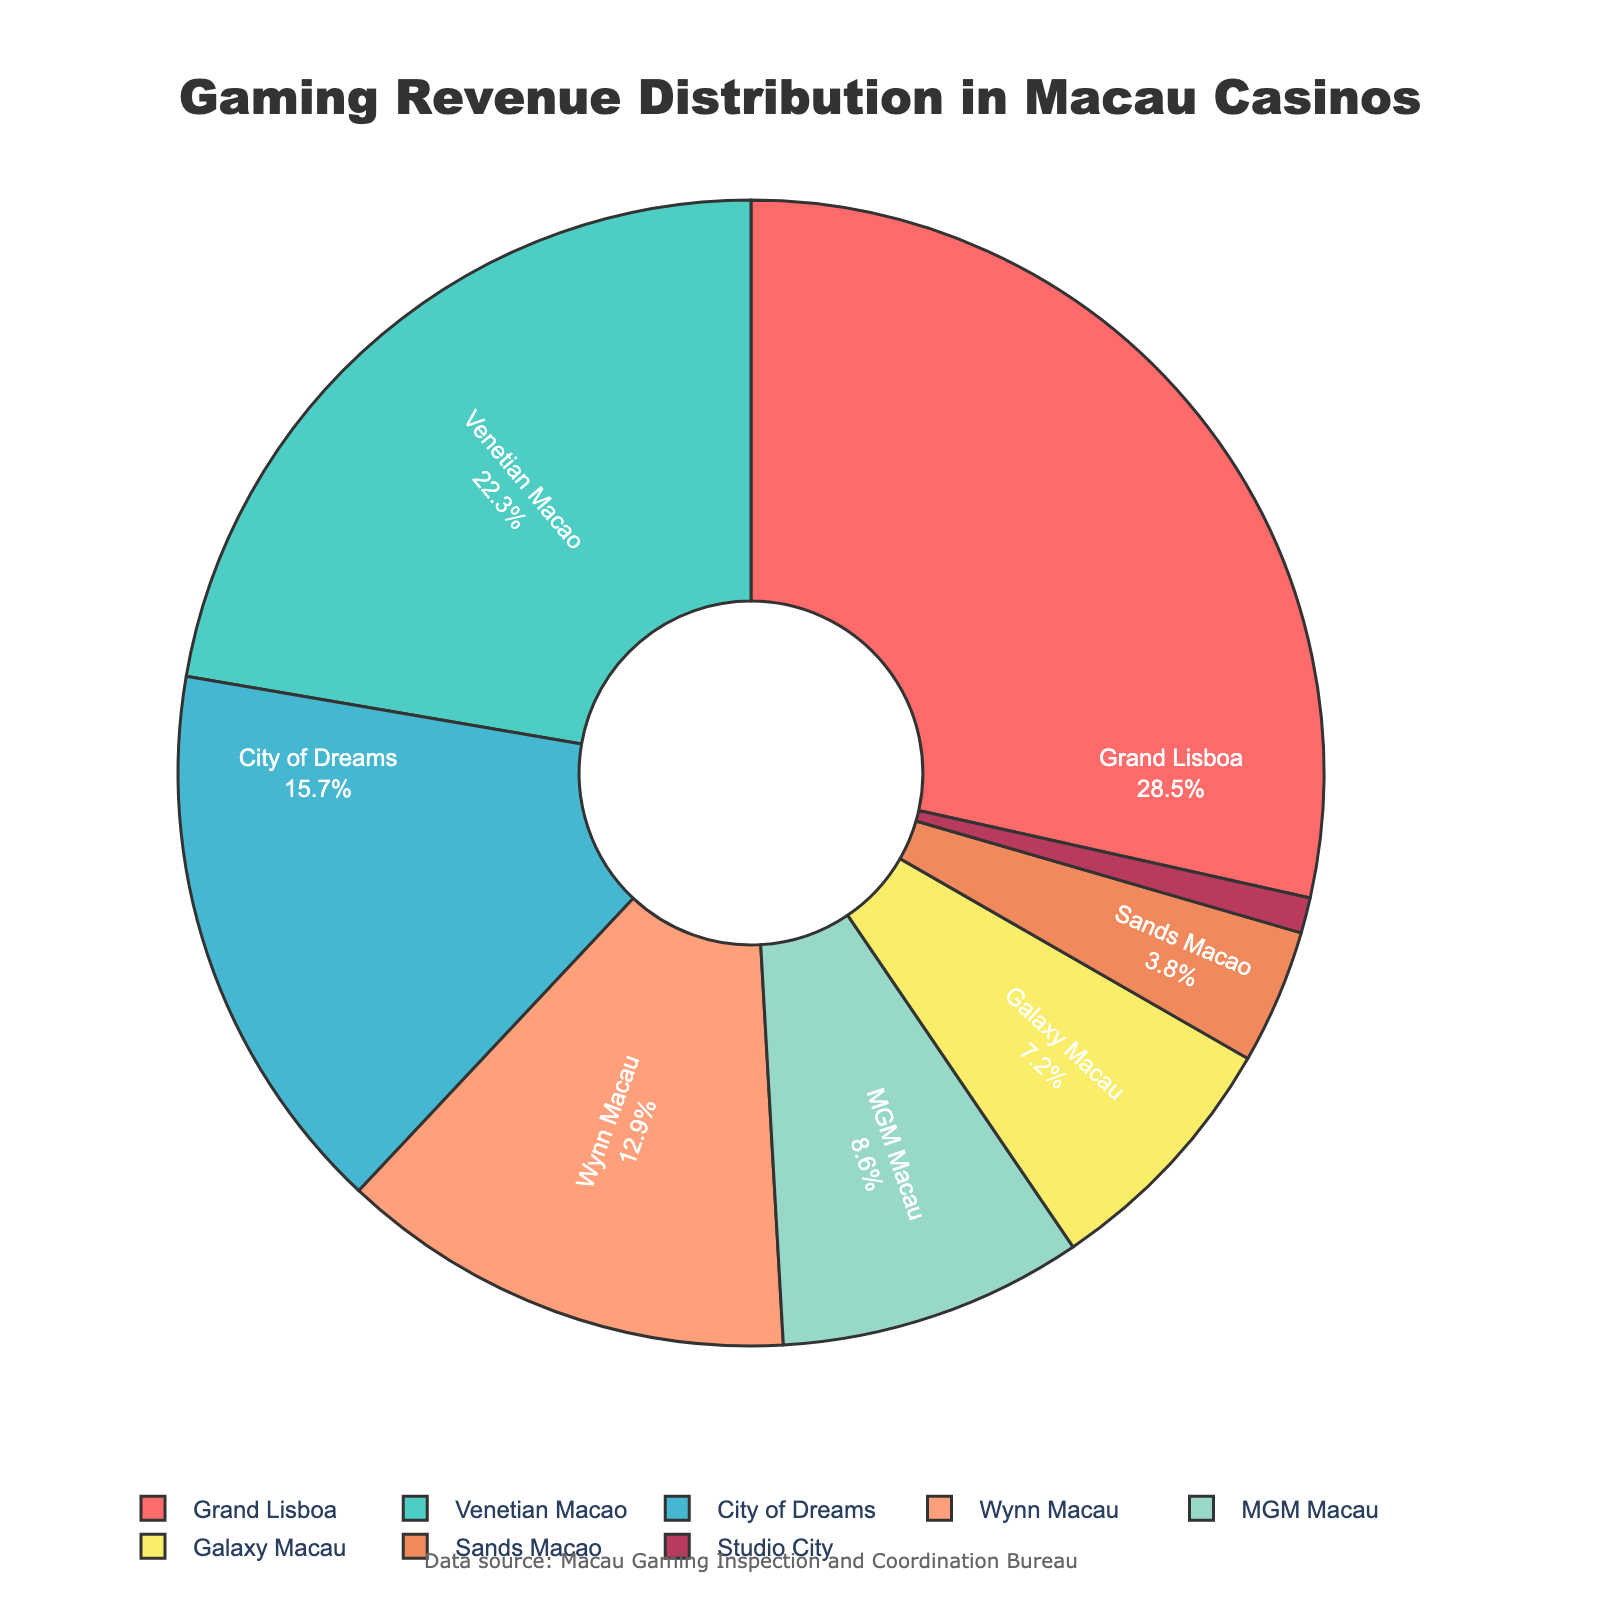Which casino type generates the highest gaming revenue? The figure shows that Grand Lisboa has the largest portion of the pie chart, indicating it has the highest percentage of gaming revenue.
Answer: Grand Lisboa What is the combined revenue percentage of Venetian Macao and MGM Macau? The revenue percentage for Venetian Macao is 22.3%, and for MGM Macau, it is 8.6%. Adding these together gives 22.3% + 8.6% = 30.9%.
Answer: 30.9% Which casino type has the smallest contribution to the gaming revenue? The smallest portion of the pie chart is labeled Studio City, which indicates it has the least revenue percentage of 1.0%.
Answer: Studio City Is the revenue percentage of Grand Lisboa greater than the combined percentage of Sands Macao and Galaxy Macau? Grand Lisboa has a revenue percentage of 28.5%. Sands Macao has 3.8%, and Galaxy Macau has 7.2%. Adding these together gives 3.8% + 7.2% = 11%. Since 28.5% is greater than 11%, the answer is yes.
Answer: Yes What is the difference in revenue percentage between Wynn Macau and City of Dreams? Wynn Macau has a revenue percentage of 12.9%, and City of Dreams has 15.7%. Subtracting 12.9% from 15.7% gives 15.7% - 12.9% = 2.8%.
Answer: 2.8% Which casino types have a revenue percentage less than 10%? The portions of the pie chart with less than 10% are MGM Macau (8.6%), Galaxy Macau (7.2%), Sands Macao (3.8%), and Studio City (1.0%).
Answer: MGM Macau, Galaxy Macau, Sands Macao, Studio City What is the average revenue percentage of Grand Lisboa, Venetian Macao, and City of Dreams? The revenue percentages are 28.5% for Grand Lisboa, 22.3% for Venetian Macao, and 15.7% for City of Dreams. Adding these gives 28.5% + 22.3% + 15.7% = 66.5%. Dividing this by 3 gives 66.5% / 3 = 22.17%.
Answer: 22.17% How much greater is the revenue percentage of Venetian Macao compared to Galaxy Macau? Venetian Macao has a percentage of 22.3%, while Galaxy Macau has 7.2%. Subtracting 7.2% from 22.3% gives 22.3% - 7.2% = 15.1%.
Answer: 15.1% What color represents Sands Macao on the pie chart? The color coded to Sands Macao in the pie chart is visually observable and is represented with a light pink or salmon color.
Answer: Salmon 